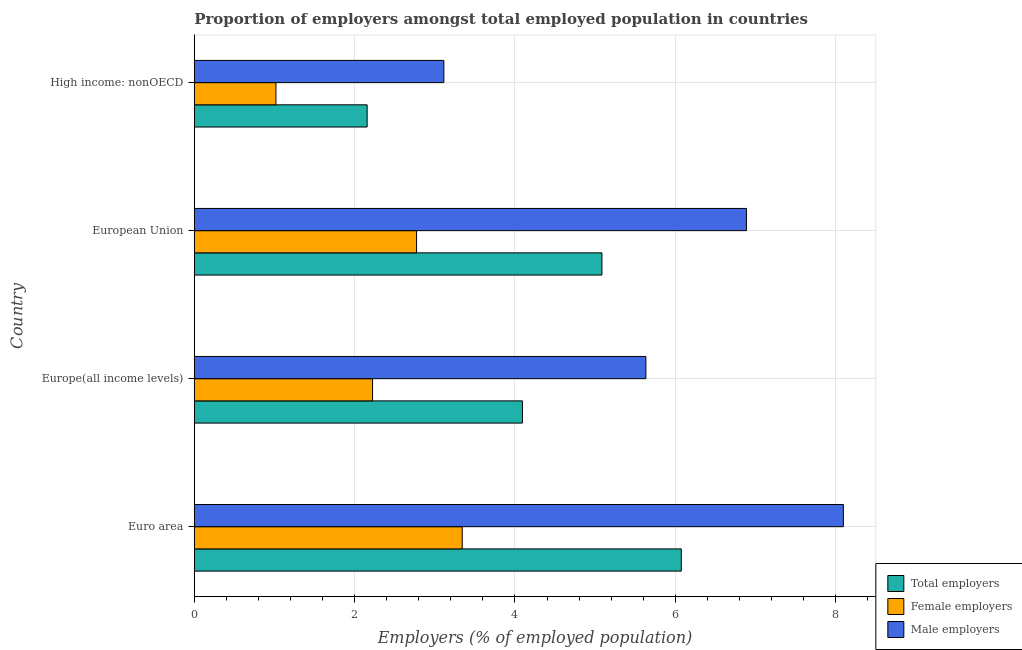How many groups of bars are there?
Provide a short and direct response. 4. How many bars are there on the 4th tick from the top?
Provide a succinct answer. 3. What is the label of the 1st group of bars from the top?
Provide a succinct answer. High income: nonOECD. What is the percentage of male employers in European Union?
Ensure brevity in your answer.  6.89. Across all countries, what is the maximum percentage of total employers?
Offer a terse response. 6.07. Across all countries, what is the minimum percentage of male employers?
Provide a short and direct response. 3.11. In which country was the percentage of total employers minimum?
Your response must be concise. High income: nonOECD. What is the total percentage of male employers in the graph?
Your answer should be very brief. 23.73. What is the difference between the percentage of female employers in European Union and that in High income: nonOECD?
Keep it short and to the point. 1.75. What is the difference between the percentage of total employers in Euro area and the percentage of female employers in Europe(all income levels)?
Provide a succinct answer. 3.85. What is the average percentage of female employers per country?
Your answer should be compact. 2.34. What is the difference between the percentage of female employers and percentage of male employers in Euro area?
Keep it short and to the point. -4.75. What is the ratio of the percentage of male employers in Europe(all income levels) to that in European Union?
Provide a succinct answer. 0.82. Is the percentage of total employers in Euro area less than that in High income: nonOECD?
Give a very brief answer. No. What is the difference between the highest and the second highest percentage of male employers?
Provide a short and direct response. 1.21. What is the difference between the highest and the lowest percentage of male employers?
Keep it short and to the point. 4.98. What does the 1st bar from the top in Euro area represents?
Give a very brief answer. Male employers. What does the 2nd bar from the bottom in High income: nonOECD represents?
Offer a terse response. Female employers. How many bars are there?
Provide a short and direct response. 12. Are all the bars in the graph horizontal?
Your answer should be compact. Yes. How many countries are there in the graph?
Give a very brief answer. 4. What is the difference between two consecutive major ticks on the X-axis?
Provide a short and direct response. 2. Are the values on the major ticks of X-axis written in scientific E-notation?
Keep it short and to the point. No. Does the graph contain any zero values?
Make the answer very short. No. Where does the legend appear in the graph?
Offer a terse response. Bottom right. How many legend labels are there?
Offer a very short reply. 3. What is the title of the graph?
Offer a very short reply. Proportion of employers amongst total employed population in countries. What is the label or title of the X-axis?
Your response must be concise. Employers (% of employed population). What is the Employers (% of employed population) in Total employers in Euro area?
Your response must be concise. 6.07. What is the Employers (% of employed population) of Female employers in Euro area?
Your answer should be compact. 3.34. What is the Employers (% of employed population) of Male employers in Euro area?
Give a very brief answer. 8.1. What is the Employers (% of employed population) in Total employers in Europe(all income levels)?
Your response must be concise. 4.09. What is the Employers (% of employed population) of Female employers in Europe(all income levels)?
Keep it short and to the point. 2.22. What is the Employers (% of employed population) in Male employers in Europe(all income levels)?
Provide a short and direct response. 5.63. What is the Employers (% of employed population) of Total employers in European Union?
Offer a terse response. 5.08. What is the Employers (% of employed population) of Female employers in European Union?
Your answer should be compact. 2.77. What is the Employers (% of employed population) of Male employers in European Union?
Keep it short and to the point. 6.89. What is the Employers (% of employed population) in Total employers in High income: nonOECD?
Offer a very short reply. 2.16. What is the Employers (% of employed population) of Female employers in High income: nonOECD?
Your answer should be very brief. 1.02. What is the Employers (% of employed population) of Male employers in High income: nonOECD?
Your answer should be very brief. 3.11. Across all countries, what is the maximum Employers (% of employed population) in Total employers?
Ensure brevity in your answer.  6.07. Across all countries, what is the maximum Employers (% of employed population) in Female employers?
Provide a short and direct response. 3.34. Across all countries, what is the maximum Employers (% of employed population) of Male employers?
Offer a terse response. 8.1. Across all countries, what is the minimum Employers (% of employed population) of Total employers?
Give a very brief answer. 2.16. Across all countries, what is the minimum Employers (% of employed population) of Female employers?
Provide a short and direct response. 1.02. Across all countries, what is the minimum Employers (% of employed population) of Male employers?
Give a very brief answer. 3.11. What is the total Employers (% of employed population) in Total employers in the graph?
Ensure brevity in your answer.  17.41. What is the total Employers (% of employed population) in Female employers in the graph?
Make the answer very short. 9.36. What is the total Employers (% of employed population) of Male employers in the graph?
Provide a succinct answer. 23.73. What is the difference between the Employers (% of employed population) in Total employers in Euro area and that in Europe(all income levels)?
Provide a succinct answer. 1.98. What is the difference between the Employers (% of employed population) of Female employers in Euro area and that in Europe(all income levels)?
Your response must be concise. 1.12. What is the difference between the Employers (% of employed population) of Male employers in Euro area and that in Europe(all income levels)?
Provide a short and direct response. 2.46. What is the difference between the Employers (% of employed population) in Female employers in Euro area and that in European Union?
Your answer should be compact. 0.57. What is the difference between the Employers (% of employed population) in Male employers in Euro area and that in European Union?
Give a very brief answer. 1.21. What is the difference between the Employers (% of employed population) in Total employers in Euro area and that in High income: nonOECD?
Offer a very short reply. 3.92. What is the difference between the Employers (% of employed population) of Female employers in Euro area and that in High income: nonOECD?
Ensure brevity in your answer.  2.32. What is the difference between the Employers (% of employed population) in Male employers in Euro area and that in High income: nonOECD?
Provide a short and direct response. 4.98. What is the difference between the Employers (% of employed population) in Total employers in Europe(all income levels) and that in European Union?
Offer a very short reply. -0.99. What is the difference between the Employers (% of employed population) of Female employers in Europe(all income levels) and that in European Union?
Ensure brevity in your answer.  -0.55. What is the difference between the Employers (% of employed population) of Male employers in Europe(all income levels) and that in European Union?
Your answer should be compact. -1.25. What is the difference between the Employers (% of employed population) in Total employers in Europe(all income levels) and that in High income: nonOECD?
Your response must be concise. 1.94. What is the difference between the Employers (% of employed population) of Female employers in Europe(all income levels) and that in High income: nonOECD?
Make the answer very short. 1.21. What is the difference between the Employers (% of employed population) in Male employers in Europe(all income levels) and that in High income: nonOECD?
Make the answer very short. 2.52. What is the difference between the Employers (% of employed population) of Total employers in European Union and that in High income: nonOECD?
Keep it short and to the point. 2.93. What is the difference between the Employers (% of employed population) in Female employers in European Union and that in High income: nonOECD?
Your answer should be very brief. 1.75. What is the difference between the Employers (% of employed population) of Male employers in European Union and that in High income: nonOECD?
Your response must be concise. 3.77. What is the difference between the Employers (% of employed population) of Total employers in Euro area and the Employers (% of employed population) of Female employers in Europe(all income levels)?
Provide a succinct answer. 3.85. What is the difference between the Employers (% of employed population) in Total employers in Euro area and the Employers (% of employed population) in Male employers in Europe(all income levels)?
Keep it short and to the point. 0.44. What is the difference between the Employers (% of employed population) in Female employers in Euro area and the Employers (% of employed population) in Male employers in Europe(all income levels)?
Give a very brief answer. -2.29. What is the difference between the Employers (% of employed population) in Total employers in Euro area and the Employers (% of employed population) in Female employers in European Union?
Ensure brevity in your answer.  3.3. What is the difference between the Employers (% of employed population) of Total employers in Euro area and the Employers (% of employed population) of Male employers in European Union?
Make the answer very short. -0.81. What is the difference between the Employers (% of employed population) in Female employers in Euro area and the Employers (% of employed population) in Male employers in European Union?
Your response must be concise. -3.55. What is the difference between the Employers (% of employed population) in Total employers in Euro area and the Employers (% of employed population) in Female employers in High income: nonOECD?
Your answer should be very brief. 5.06. What is the difference between the Employers (% of employed population) in Total employers in Euro area and the Employers (% of employed population) in Male employers in High income: nonOECD?
Provide a short and direct response. 2.96. What is the difference between the Employers (% of employed population) of Female employers in Euro area and the Employers (% of employed population) of Male employers in High income: nonOECD?
Give a very brief answer. 0.23. What is the difference between the Employers (% of employed population) in Total employers in Europe(all income levels) and the Employers (% of employed population) in Female employers in European Union?
Give a very brief answer. 1.32. What is the difference between the Employers (% of employed population) in Total employers in Europe(all income levels) and the Employers (% of employed population) in Male employers in European Union?
Ensure brevity in your answer.  -2.79. What is the difference between the Employers (% of employed population) in Female employers in Europe(all income levels) and the Employers (% of employed population) in Male employers in European Union?
Your response must be concise. -4.66. What is the difference between the Employers (% of employed population) in Total employers in Europe(all income levels) and the Employers (% of employed population) in Female employers in High income: nonOECD?
Your answer should be compact. 3.07. What is the difference between the Employers (% of employed population) of Total employers in Europe(all income levels) and the Employers (% of employed population) of Male employers in High income: nonOECD?
Your answer should be very brief. 0.98. What is the difference between the Employers (% of employed population) in Female employers in Europe(all income levels) and the Employers (% of employed population) in Male employers in High income: nonOECD?
Keep it short and to the point. -0.89. What is the difference between the Employers (% of employed population) of Total employers in European Union and the Employers (% of employed population) of Female employers in High income: nonOECD?
Offer a terse response. 4.07. What is the difference between the Employers (% of employed population) of Total employers in European Union and the Employers (% of employed population) of Male employers in High income: nonOECD?
Your response must be concise. 1.97. What is the difference between the Employers (% of employed population) in Female employers in European Union and the Employers (% of employed population) in Male employers in High income: nonOECD?
Your answer should be compact. -0.34. What is the average Employers (% of employed population) in Total employers per country?
Make the answer very short. 4.35. What is the average Employers (% of employed population) in Female employers per country?
Give a very brief answer. 2.34. What is the average Employers (% of employed population) in Male employers per country?
Make the answer very short. 5.93. What is the difference between the Employers (% of employed population) of Total employers and Employers (% of employed population) of Female employers in Euro area?
Give a very brief answer. 2.73. What is the difference between the Employers (% of employed population) in Total employers and Employers (% of employed population) in Male employers in Euro area?
Provide a succinct answer. -2.02. What is the difference between the Employers (% of employed population) in Female employers and Employers (% of employed population) in Male employers in Euro area?
Provide a short and direct response. -4.75. What is the difference between the Employers (% of employed population) in Total employers and Employers (% of employed population) in Female employers in Europe(all income levels)?
Make the answer very short. 1.87. What is the difference between the Employers (% of employed population) of Total employers and Employers (% of employed population) of Male employers in Europe(all income levels)?
Provide a succinct answer. -1.54. What is the difference between the Employers (% of employed population) of Female employers and Employers (% of employed population) of Male employers in Europe(all income levels)?
Offer a terse response. -3.41. What is the difference between the Employers (% of employed population) in Total employers and Employers (% of employed population) in Female employers in European Union?
Provide a succinct answer. 2.31. What is the difference between the Employers (% of employed population) in Total employers and Employers (% of employed population) in Male employers in European Union?
Give a very brief answer. -1.8. What is the difference between the Employers (% of employed population) of Female employers and Employers (% of employed population) of Male employers in European Union?
Your answer should be compact. -4.11. What is the difference between the Employers (% of employed population) in Total employers and Employers (% of employed population) in Female employers in High income: nonOECD?
Keep it short and to the point. 1.14. What is the difference between the Employers (% of employed population) of Total employers and Employers (% of employed population) of Male employers in High income: nonOECD?
Keep it short and to the point. -0.96. What is the difference between the Employers (% of employed population) of Female employers and Employers (% of employed population) of Male employers in High income: nonOECD?
Offer a very short reply. -2.09. What is the ratio of the Employers (% of employed population) in Total employers in Euro area to that in Europe(all income levels)?
Make the answer very short. 1.48. What is the ratio of the Employers (% of employed population) of Female employers in Euro area to that in Europe(all income levels)?
Give a very brief answer. 1.5. What is the ratio of the Employers (% of employed population) of Male employers in Euro area to that in Europe(all income levels)?
Your response must be concise. 1.44. What is the ratio of the Employers (% of employed population) in Total employers in Euro area to that in European Union?
Provide a succinct answer. 1.19. What is the ratio of the Employers (% of employed population) of Female employers in Euro area to that in European Union?
Ensure brevity in your answer.  1.21. What is the ratio of the Employers (% of employed population) in Male employers in Euro area to that in European Union?
Provide a succinct answer. 1.18. What is the ratio of the Employers (% of employed population) of Total employers in Euro area to that in High income: nonOECD?
Ensure brevity in your answer.  2.82. What is the ratio of the Employers (% of employed population) of Female employers in Euro area to that in High income: nonOECD?
Offer a very short reply. 3.28. What is the ratio of the Employers (% of employed population) in Male employers in Euro area to that in High income: nonOECD?
Give a very brief answer. 2.6. What is the ratio of the Employers (% of employed population) of Total employers in Europe(all income levels) to that in European Union?
Keep it short and to the point. 0.81. What is the ratio of the Employers (% of employed population) in Female employers in Europe(all income levels) to that in European Union?
Make the answer very short. 0.8. What is the ratio of the Employers (% of employed population) of Male employers in Europe(all income levels) to that in European Union?
Offer a very short reply. 0.82. What is the ratio of the Employers (% of employed population) of Total employers in Europe(all income levels) to that in High income: nonOECD?
Your answer should be very brief. 1.9. What is the ratio of the Employers (% of employed population) in Female employers in Europe(all income levels) to that in High income: nonOECD?
Your response must be concise. 2.18. What is the ratio of the Employers (% of employed population) in Male employers in Europe(all income levels) to that in High income: nonOECD?
Provide a succinct answer. 1.81. What is the ratio of the Employers (% of employed population) in Total employers in European Union to that in High income: nonOECD?
Your response must be concise. 2.36. What is the ratio of the Employers (% of employed population) in Female employers in European Union to that in High income: nonOECD?
Make the answer very short. 2.72. What is the ratio of the Employers (% of employed population) of Male employers in European Union to that in High income: nonOECD?
Your response must be concise. 2.21. What is the difference between the highest and the second highest Employers (% of employed population) in Female employers?
Offer a very short reply. 0.57. What is the difference between the highest and the second highest Employers (% of employed population) in Male employers?
Ensure brevity in your answer.  1.21. What is the difference between the highest and the lowest Employers (% of employed population) of Total employers?
Give a very brief answer. 3.92. What is the difference between the highest and the lowest Employers (% of employed population) of Female employers?
Your response must be concise. 2.32. What is the difference between the highest and the lowest Employers (% of employed population) in Male employers?
Offer a very short reply. 4.98. 